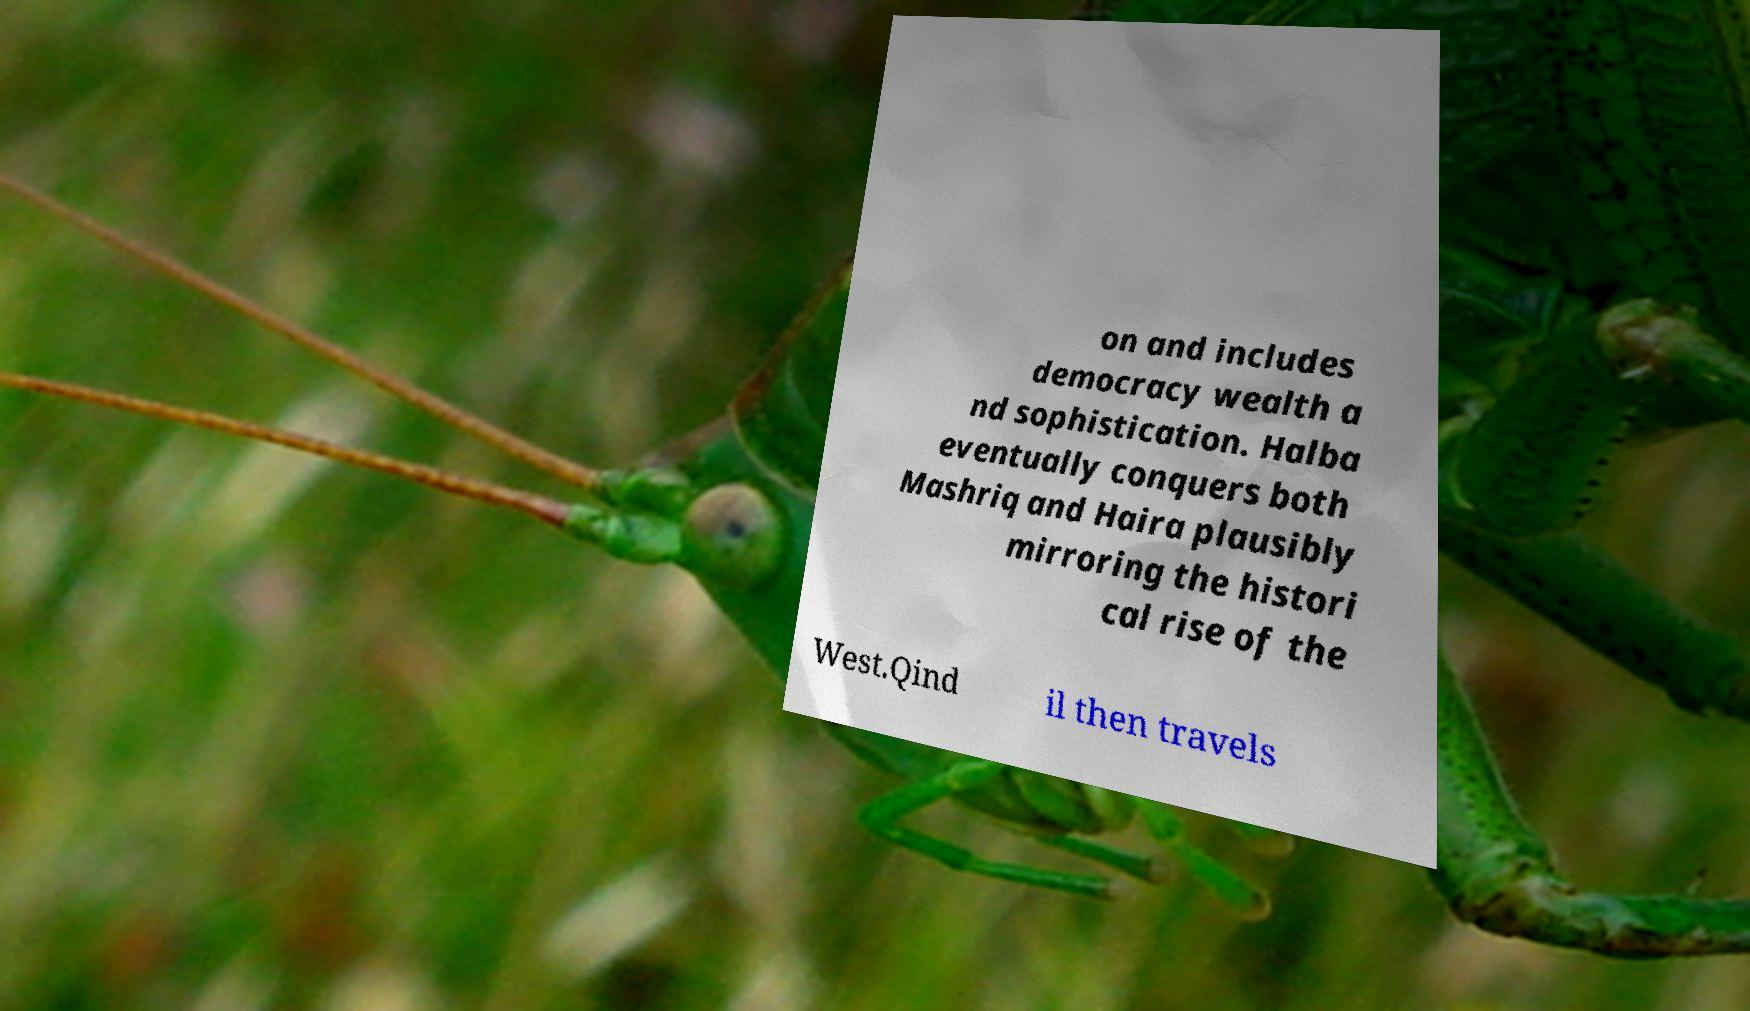Could you extract and type out the text from this image? on and includes democracy wealth a nd sophistication. Halba eventually conquers both Mashriq and Haira plausibly mirroring the histori cal rise of the West.Qind il then travels 